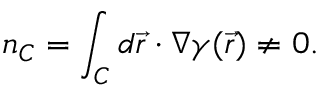Convert formula to latex. <formula><loc_0><loc_0><loc_500><loc_500>n _ { C } = \int _ { C } d \vec { r } \cdot \nabla \gamma ( \vec { r } ) \neq 0 .</formula> 